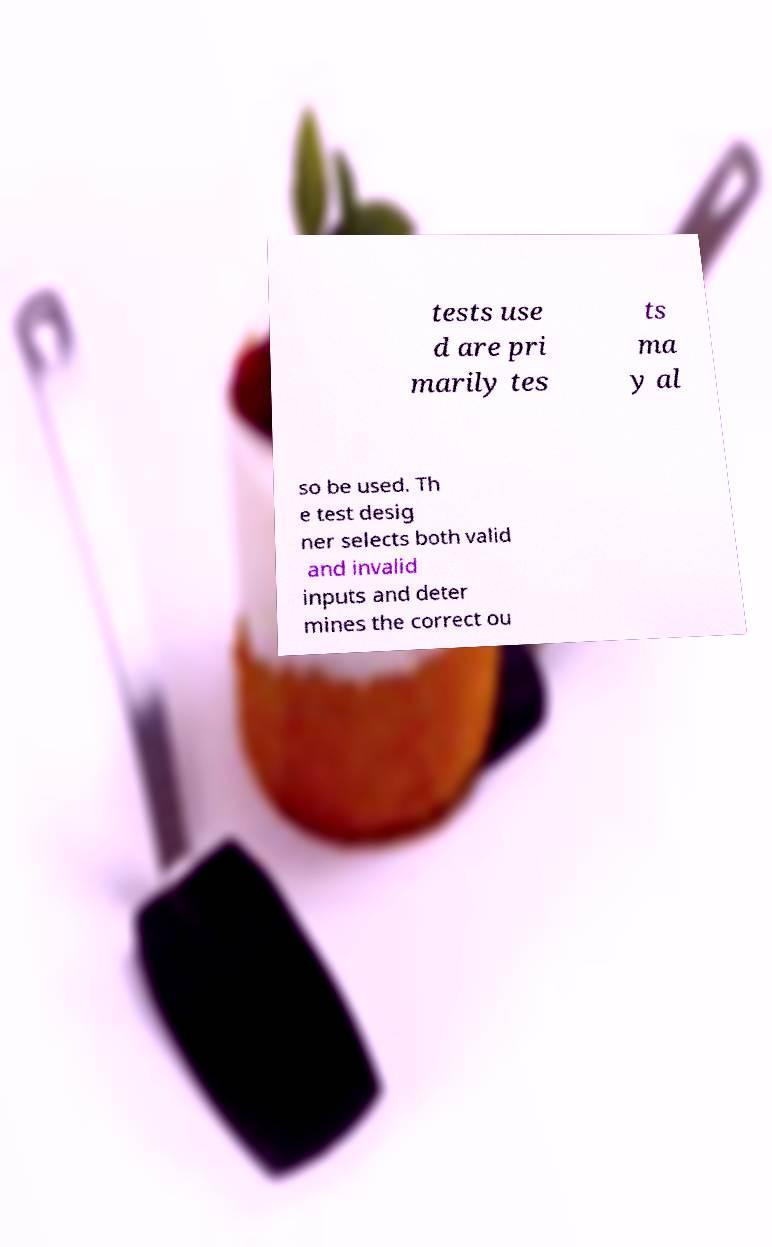For documentation purposes, I need the text within this image transcribed. Could you provide that? tests use d are pri marily tes ts ma y al so be used. Th e test desig ner selects both valid and invalid inputs and deter mines the correct ou 